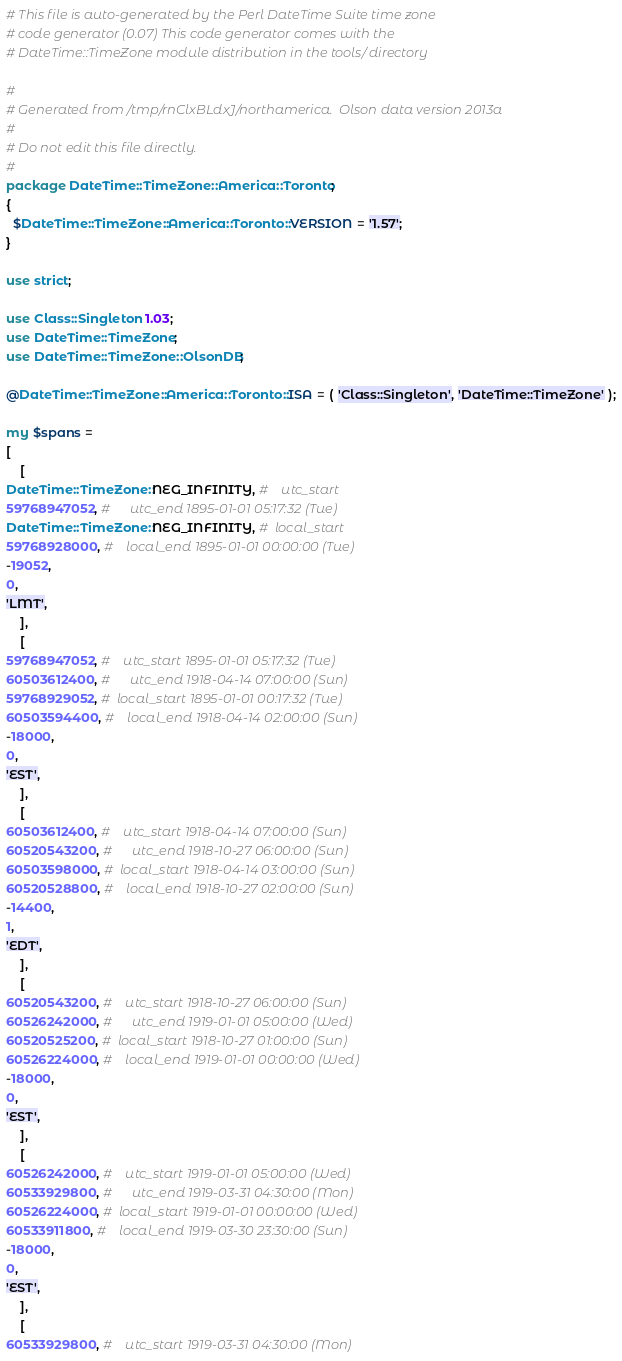Convert code to text. <code><loc_0><loc_0><loc_500><loc_500><_Perl_># This file is auto-generated by the Perl DateTime Suite time zone
# code generator (0.07) This code generator comes with the
# DateTime::TimeZone module distribution in the tools/ directory

#
# Generated from /tmp/rnClxBLdxJ/northamerica.  Olson data version 2013a
#
# Do not edit this file directly.
#
package DateTime::TimeZone::America::Toronto;
{
  $DateTime::TimeZone::America::Toronto::VERSION = '1.57';
}

use strict;

use Class::Singleton 1.03;
use DateTime::TimeZone;
use DateTime::TimeZone::OlsonDB;

@DateTime::TimeZone::America::Toronto::ISA = ( 'Class::Singleton', 'DateTime::TimeZone' );

my $spans =
[
    [
DateTime::TimeZone::NEG_INFINITY, #    utc_start
59768947052, #      utc_end 1895-01-01 05:17:32 (Tue)
DateTime::TimeZone::NEG_INFINITY, #  local_start
59768928000, #    local_end 1895-01-01 00:00:00 (Tue)
-19052,
0,
'LMT',
    ],
    [
59768947052, #    utc_start 1895-01-01 05:17:32 (Tue)
60503612400, #      utc_end 1918-04-14 07:00:00 (Sun)
59768929052, #  local_start 1895-01-01 00:17:32 (Tue)
60503594400, #    local_end 1918-04-14 02:00:00 (Sun)
-18000,
0,
'EST',
    ],
    [
60503612400, #    utc_start 1918-04-14 07:00:00 (Sun)
60520543200, #      utc_end 1918-10-27 06:00:00 (Sun)
60503598000, #  local_start 1918-04-14 03:00:00 (Sun)
60520528800, #    local_end 1918-10-27 02:00:00 (Sun)
-14400,
1,
'EDT',
    ],
    [
60520543200, #    utc_start 1918-10-27 06:00:00 (Sun)
60526242000, #      utc_end 1919-01-01 05:00:00 (Wed)
60520525200, #  local_start 1918-10-27 01:00:00 (Sun)
60526224000, #    local_end 1919-01-01 00:00:00 (Wed)
-18000,
0,
'EST',
    ],
    [
60526242000, #    utc_start 1919-01-01 05:00:00 (Wed)
60533929800, #      utc_end 1919-03-31 04:30:00 (Mon)
60526224000, #  local_start 1919-01-01 00:00:00 (Wed)
60533911800, #    local_end 1919-03-30 23:30:00 (Sun)
-18000,
0,
'EST',
    ],
    [
60533929800, #    utc_start 1919-03-31 04:30:00 (Mon)</code> 